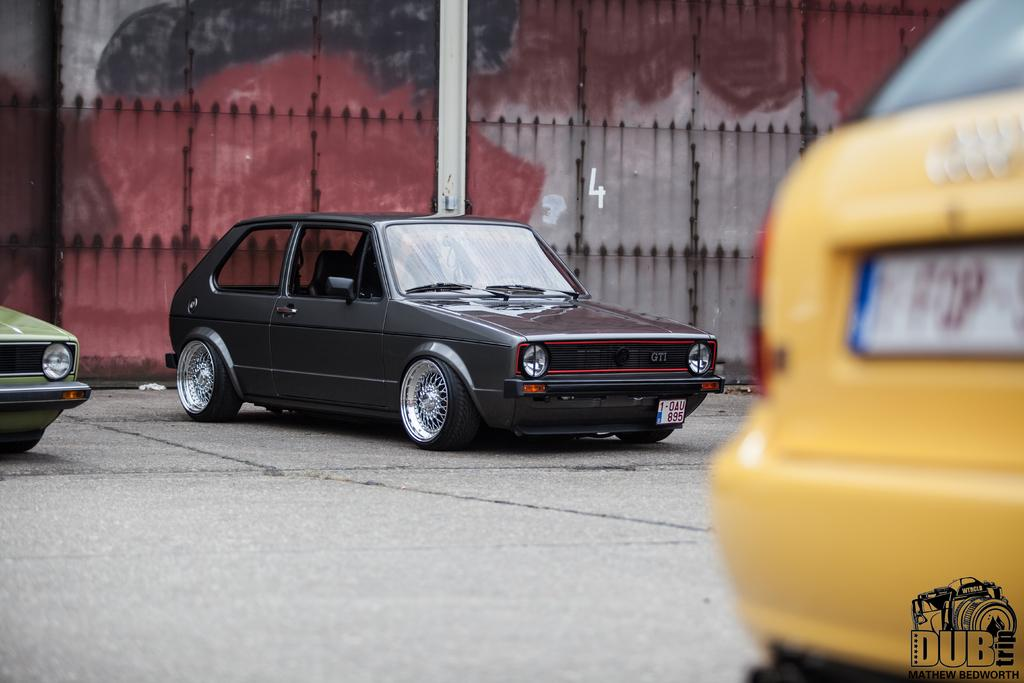What can be seen in the center of the image? There are cars on the road in the center of the image. What is visible in the background of the image? There is a fence and a pole in the background of the image. What is the color of the pole? The pole is white in color. What type of meat is hanging from the fence in the image? There is no meat present in the image; it only features a fence and a pole in the background. 